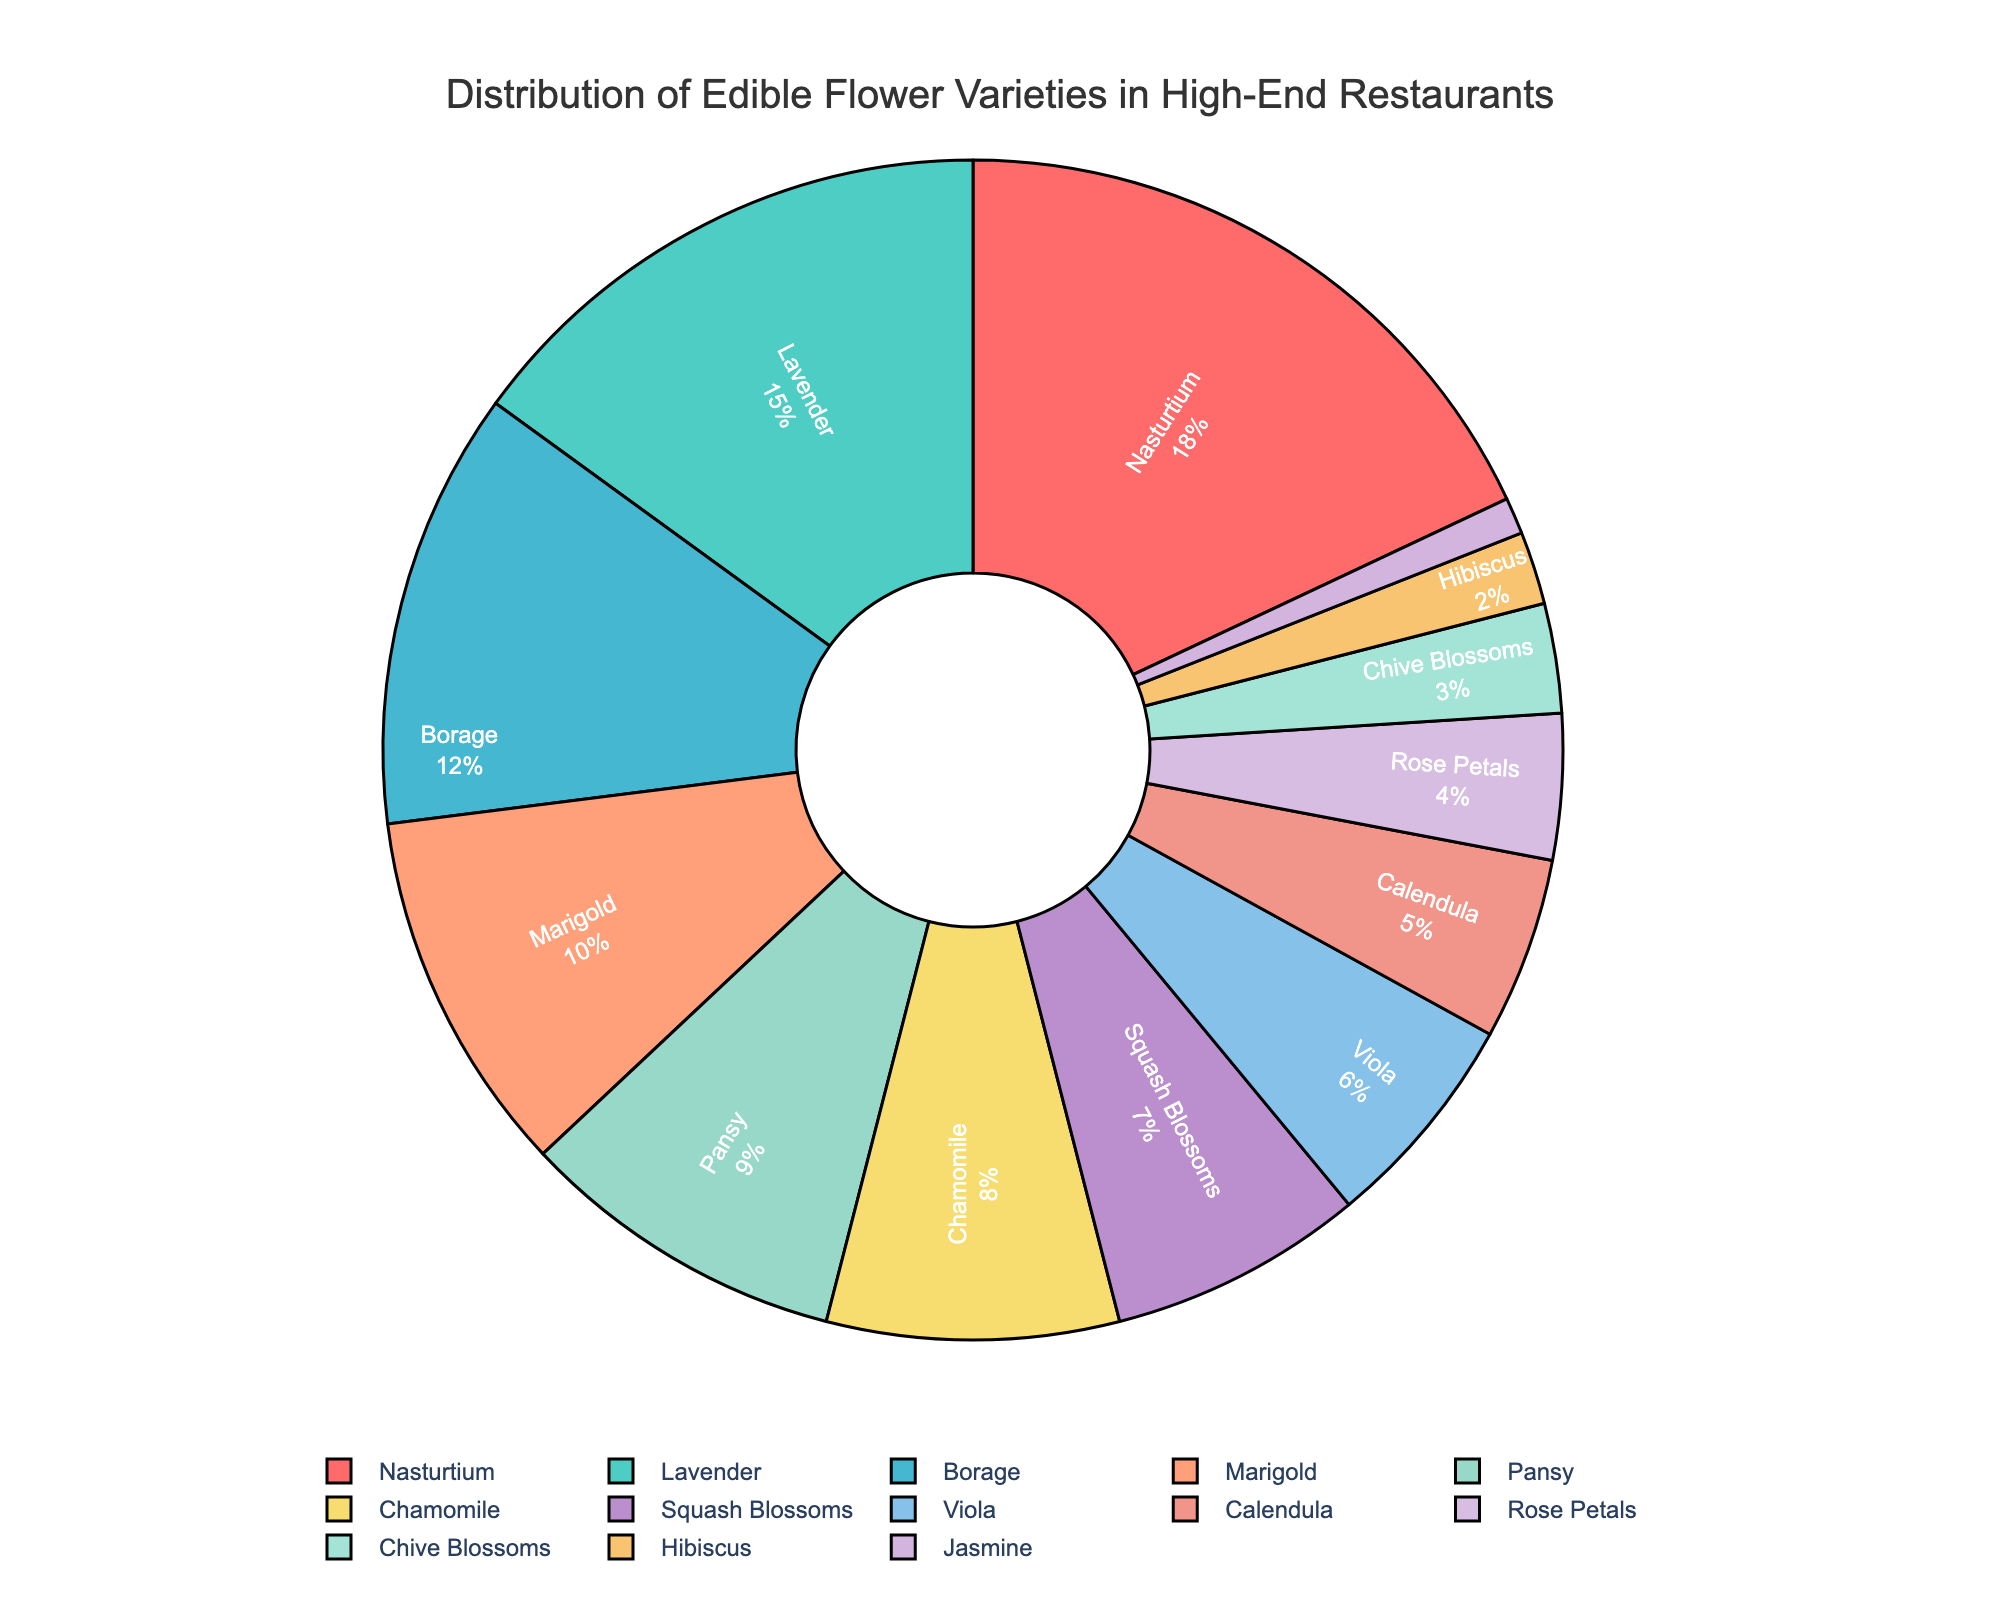Which edible flower variety is used the most in high-end restaurants? The flower with the largest percentage slice in the pie chart represents the most used variety. Nasturtium has the largest slice.
Answer: Nasturtium How much more is the percentage of Nasturtium compared to Jasmine? The percentage of Nasturtium is 18% and Jasmine is 1%. The difference is 18% - 1% = 17%.
Answer: 17% Which two flower varieties together make up nearly one-third of the total usage? Summing percentages to find a combination close to 33%. Nasturtium (18%) + Lavender (15%) = 33%.
Answer: Nasturtium and Lavender What is the combined percentage of Chamomile and Squash Blossoms? The percentage of Chamomile is 8% and Squash Blossoms is 7%. Their combined percentage is 8% + 7% = 15%.
Answer: 15% Which flower variety has a yellow slice in the pie chart? Calendula is a yellow-orange flower and its corresponding color slice should be yellowish.
Answer: Calendula Are there more flower varieties with a percentage less than or equal to 5% or greater than 5%? Counting the number of flower varieties in each category. Varieties ≤5% (Jasmine, Hibiscus, Chive Blossoms, Rose Petals, Calendula) = 5. Varieties >5% (Viola, Squash Blossoms, Chamomile, Pansy, Marigold, Borage, Lavender, Nasturtium) = 8.
Answer: Greater than 5% Which flower varieties have percentages between 5% and 10%? Checking the pie chart slices for flowers with percentages in this range. Those are Viola (6%), Calendula (5%), Pansy (9%), and Marigold (10%).
Answer: Pansy, Marigold, Viola Is the percentage usage of Borage closer to that of Lavender or Squash Blossoms? Borage is 12%, Lavender is 15%, Squash Blossoms is 7%. Difference between Borage and Lavender = 3%, difference between Borage and Squash Blossoms = 5%.
Answer: Lavender What is the average percentage of usage for the four least common flower varieties? Identifying the four least common: Jasmine (1%), Hibiscus (2%), Chive Blossoms (3%), Rose Petals (4%). Average = (1% + 2% + 3% + 4%) / 4 = 2.5%.
Answer: 2.5% Which varieties have a total percentage usage equal to that of Lavender? Lavender has 15%. Identifying varieties that sum to 15%, one option is Chamomile (8%) + Squash Blossoms (7%) = 15%.
Answer: Chamomile and Squash Blossoms 